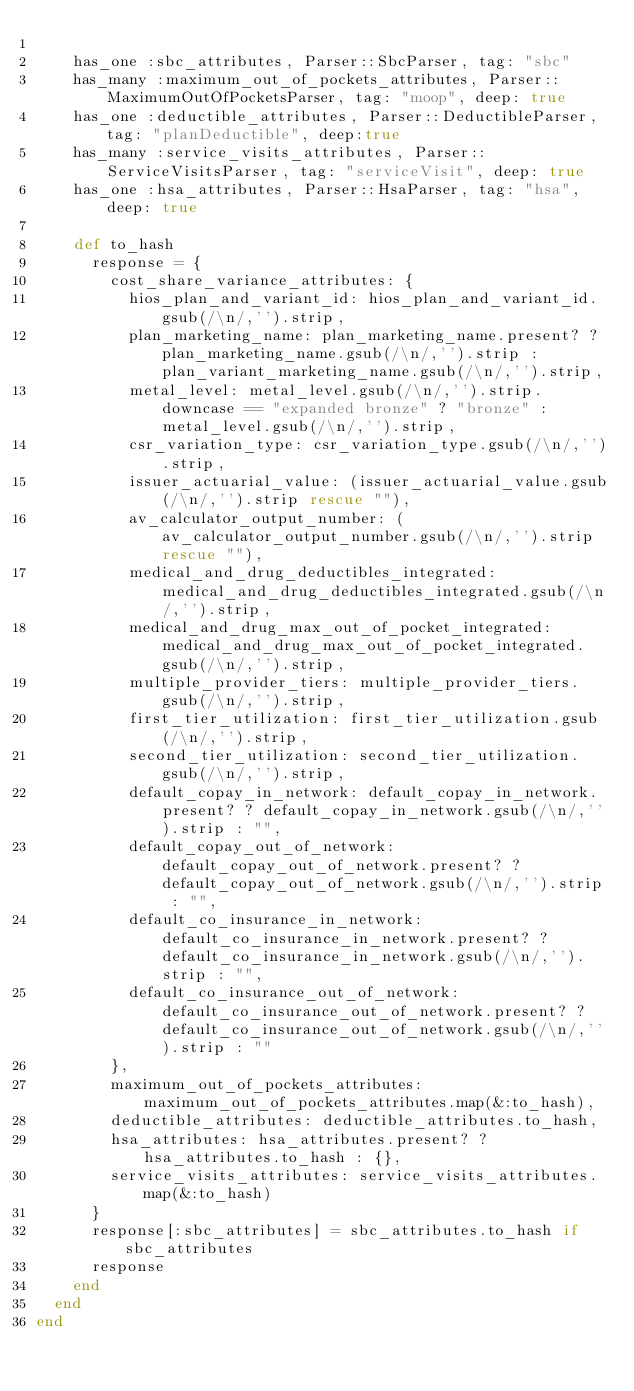Convert code to text. <code><loc_0><loc_0><loc_500><loc_500><_Ruby_>
    has_one :sbc_attributes, Parser::SbcParser, tag: "sbc"
    has_many :maximum_out_of_pockets_attributes, Parser::MaximumOutOfPocketsParser, tag: "moop", deep: true
    has_one :deductible_attributes, Parser::DeductibleParser, tag: "planDeductible", deep:true
    has_many :service_visits_attributes, Parser::ServiceVisitsParser, tag: "serviceVisit", deep: true
    has_one :hsa_attributes, Parser::HsaParser, tag: "hsa", deep: true

    def to_hash
      response = {
        cost_share_variance_attributes: {
          hios_plan_and_variant_id: hios_plan_and_variant_id.gsub(/\n/,'').strip,
          plan_marketing_name: plan_marketing_name.present? ? plan_marketing_name.gsub(/\n/,'').strip : plan_variant_marketing_name.gsub(/\n/,'').strip,
          metal_level: metal_level.gsub(/\n/,'').strip.downcase == "expanded bronze" ? "bronze" : metal_level.gsub(/\n/,'').strip,
          csr_variation_type: csr_variation_type.gsub(/\n/,'').strip,
          issuer_actuarial_value: (issuer_actuarial_value.gsub(/\n/,'').strip rescue ""),
          av_calculator_output_number: (av_calculator_output_number.gsub(/\n/,'').strip rescue ""),
          medical_and_drug_deductibles_integrated: medical_and_drug_deductibles_integrated.gsub(/\n/,'').strip,
          medical_and_drug_max_out_of_pocket_integrated: medical_and_drug_max_out_of_pocket_integrated.gsub(/\n/,'').strip,
          multiple_provider_tiers: multiple_provider_tiers.gsub(/\n/,'').strip,
          first_tier_utilization: first_tier_utilization.gsub(/\n/,'').strip,
          second_tier_utilization: second_tier_utilization.gsub(/\n/,'').strip,
          default_copay_in_network: default_copay_in_network.present? ? default_copay_in_network.gsub(/\n/,'').strip : "",
          default_copay_out_of_network: default_copay_out_of_network.present? ? default_copay_out_of_network.gsub(/\n/,'').strip : "",
          default_co_insurance_in_network: default_co_insurance_in_network.present? ? default_co_insurance_in_network.gsub(/\n/,'').strip : "",
          default_co_insurance_out_of_network: default_co_insurance_out_of_network.present? ? default_co_insurance_out_of_network.gsub(/\n/,'').strip : ""
        },
        maximum_out_of_pockets_attributes: maximum_out_of_pockets_attributes.map(&:to_hash),
        deductible_attributes: deductible_attributes.to_hash,
        hsa_attributes: hsa_attributes.present? ? hsa_attributes.to_hash : {},
        service_visits_attributes: service_visits_attributes.map(&:to_hash)
      }
      response[:sbc_attributes] = sbc_attributes.to_hash if sbc_attributes
      response
    end
  end
end
</code> 